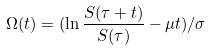<formula> <loc_0><loc_0><loc_500><loc_500>\Omega ( t ) = ( \ln \frac { S ( \tau + t ) } { S ( \tau ) } - \mu t ) / \sigma</formula> 